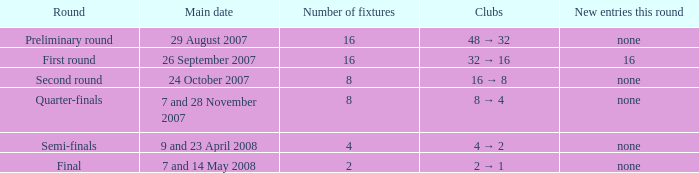What is the sum of Number of fixtures when the rounds shows quarter-finals? 8.0. 